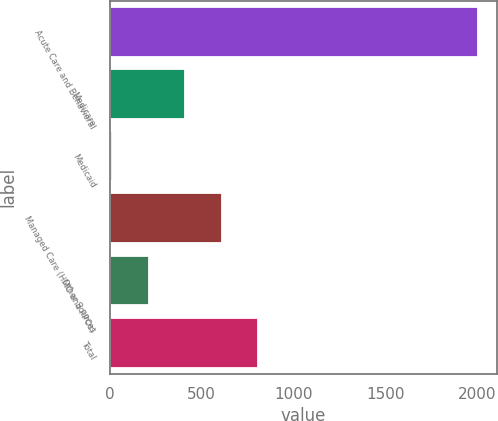Convert chart. <chart><loc_0><loc_0><loc_500><loc_500><bar_chart><fcel>Acute Care and Behavioral<fcel>Medicare<fcel>Medicaid<fcel>Managed Care (HMO and PPOs)<fcel>Other Sources<fcel>Total<nl><fcel>2005<fcel>409.8<fcel>11<fcel>609.2<fcel>210.4<fcel>808.6<nl></chart> 